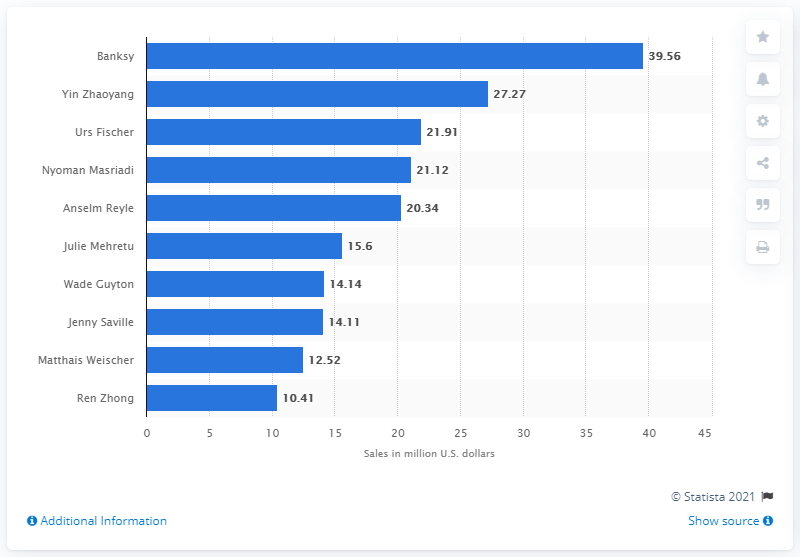Highlight a few significant elements in this photo. Banksy's art had sold a total of 39.56 million in the United States as of September 30, 2013. 